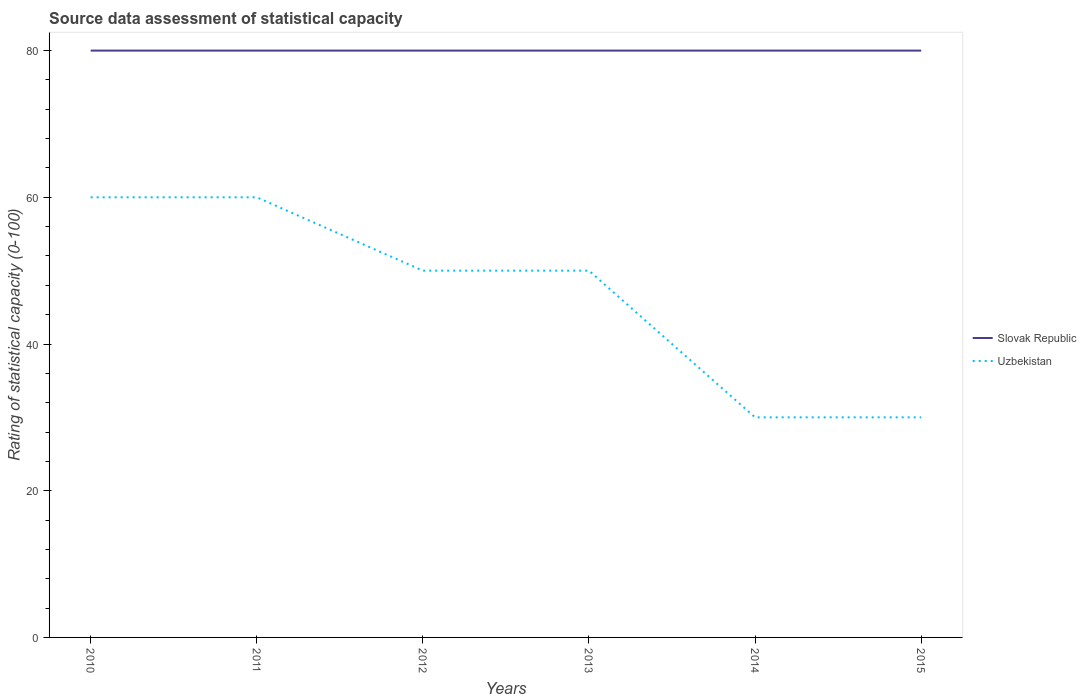Does the line corresponding to Slovak Republic intersect with the line corresponding to Uzbekistan?
Offer a very short reply. No. Is the number of lines equal to the number of legend labels?
Your answer should be compact. Yes. Across all years, what is the maximum rating of statistical capacity in Uzbekistan?
Your response must be concise. 30. In which year was the rating of statistical capacity in Uzbekistan maximum?
Provide a succinct answer. 2014. What is the difference between the highest and the lowest rating of statistical capacity in Slovak Republic?
Provide a short and direct response. 0. How many years are there in the graph?
Your answer should be compact. 6. What is the difference between two consecutive major ticks on the Y-axis?
Make the answer very short. 20. Are the values on the major ticks of Y-axis written in scientific E-notation?
Your response must be concise. No. Does the graph contain any zero values?
Make the answer very short. No. Where does the legend appear in the graph?
Keep it short and to the point. Center right. How are the legend labels stacked?
Your answer should be very brief. Vertical. What is the title of the graph?
Offer a very short reply. Source data assessment of statistical capacity. What is the label or title of the Y-axis?
Give a very brief answer. Rating of statistical capacity (0-100). What is the Rating of statistical capacity (0-100) in Slovak Republic in 2010?
Give a very brief answer. 80. What is the Rating of statistical capacity (0-100) of Uzbekistan in 2010?
Offer a very short reply. 60. What is the Rating of statistical capacity (0-100) of Slovak Republic in 2012?
Keep it short and to the point. 80. What is the Rating of statistical capacity (0-100) in Uzbekistan in 2012?
Your response must be concise. 50. What is the Rating of statistical capacity (0-100) of Slovak Republic in 2014?
Offer a terse response. 80. What is the Rating of statistical capacity (0-100) in Uzbekistan in 2014?
Your answer should be compact. 30. What is the Rating of statistical capacity (0-100) in Uzbekistan in 2015?
Offer a terse response. 30. Across all years, what is the minimum Rating of statistical capacity (0-100) in Slovak Republic?
Provide a short and direct response. 80. Across all years, what is the minimum Rating of statistical capacity (0-100) in Uzbekistan?
Offer a very short reply. 30. What is the total Rating of statistical capacity (0-100) of Slovak Republic in the graph?
Ensure brevity in your answer.  480. What is the total Rating of statistical capacity (0-100) of Uzbekistan in the graph?
Offer a very short reply. 280. What is the difference between the Rating of statistical capacity (0-100) in Slovak Republic in 2010 and that in 2011?
Provide a short and direct response. 0. What is the difference between the Rating of statistical capacity (0-100) in Uzbekistan in 2010 and that in 2011?
Your answer should be very brief. 0. What is the difference between the Rating of statistical capacity (0-100) of Slovak Republic in 2010 and that in 2012?
Give a very brief answer. 0. What is the difference between the Rating of statistical capacity (0-100) in Slovak Republic in 2010 and that in 2013?
Your answer should be compact. 0. What is the difference between the Rating of statistical capacity (0-100) in Slovak Republic in 2010 and that in 2014?
Your answer should be very brief. 0. What is the difference between the Rating of statistical capacity (0-100) in Slovak Republic in 2010 and that in 2015?
Your response must be concise. 0. What is the difference between the Rating of statistical capacity (0-100) of Slovak Republic in 2011 and that in 2012?
Provide a succinct answer. 0. What is the difference between the Rating of statistical capacity (0-100) in Slovak Republic in 2011 and that in 2013?
Give a very brief answer. 0. What is the difference between the Rating of statistical capacity (0-100) of Uzbekistan in 2011 and that in 2013?
Give a very brief answer. 10. What is the difference between the Rating of statistical capacity (0-100) of Slovak Republic in 2011 and that in 2014?
Provide a succinct answer. 0. What is the difference between the Rating of statistical capacity (0-100) in Uzbekistan in 2011 and that in 2014?
Make the answer very short. 30. What is the difference between the Rating of statistical capacity (0-100) of Uzbekistan in 2012 and that in 2015?
Keep it short and to the point. 20. What is the difference between the Rating of statistical capacity (0-100) of Slovak Republic in 2013 and that in 2015?
Offer a terse response. 0. What is the difference between the Rating of statistical capacity (0-100) in Uzbekistan in 2013 and that in 2015?
Offer a very short reply. 20. What is the difference between the Rating of statistical capacity (0-100) in Slovak Republic in 2010 and the Rating of statistical capacity (0-100) in Uzbekistan in 2015?
Give a very brief answer. 50. What is the difference between the Rating of statistical capacity (0-100) in Slovak Republic in 2011 and the Rating of statistical capacity (0-100) in Uzbekistan in 2012?
Give a very brief answer. 30. What is the difference between the Rating of statistical capacity (0-100) in Slovak Republic in 2011 and the Rating of statistical capacity (0-100) in Uzbekistan in 2013?
Your answer should be very brief. 30. What is the difference between the Rating of statistical capacity (0-100) of Slovak Republic in 2012 and the Rating of statistical capacity (0-100) of Uzbekistan in 2013?
Provide a short and direct response. 30. What is the difference between the Rating of statistical capacity (0-100) in Slovak Republic in 2012 and the Rating of statistical capacity (0-100) in Uzbekistan in 2014?
Ensure brevity in your answer.  50. What is the difference between the Rating of statistical capacity (0-100) of Slovak Republic in 2012 and the Rating of statistical capacity (0-100) of Uzbekistan in 2015?
Keep it short and to the point. 50. What is the difference between the Rating of statistical capacity (0-100) of Slovak Republic in 2013 and the Rating of statistical capacity (0-100) of Uzbekistan in 2014?
Your answer should be very brief. 50. What is the average Rating of statistical capacity (0-100) of Uzbekistan per year?
Offer a terse response. 46.67. In the year 2010, what is the difference between the Rating of statistical capacity (0-100) of Slovak Republic and Rating of statistical capacity (0-100) of Uzbekistan?
Give a very brief answer. 20. In the year 2011, what is the difference between the Rating of statistical capacity (0-100) in Slovak Republic and Rating of statistical capacity (0-100) in Uzbekistan?
Your response must be concise. 20. What is the ratio of the Rating of statistical capacity (0-100) of Slovak Republic in 2010 to that in 2011?
Offer a terse response. 1. What is the ratio of the Rating of statistical capacity (0-100) of Slovak Republic in 2010 to that in 2012?
Provide a succinct answer. 1. What is the ratio of the Rating of statistical capacity (0-100) in Slovak Republic in 2010 to that in 2014?
Your response must be concise. 1. What is the ratio of the Rating of statistical capacity (0-100) in Uzbekistan in 2010 to that in 2014?
Offer a very short reply. 2. What is the ratio of the Rating of statistical capacity (0-100) of Slovak Republic in 2010 to that in 2015?
Offer a terse response. 1. What is the ratio of the Rating of statistical capacity (0-100) in Slovak Republic in 2011 to that in 2013?
Ensure brevity in your answer.  1. What is the ratio of the Rating of statistical capacity (0-100) of Uzbekistan in 2011 to that in 2013?
Your response must be concise. 1.2. What is the ratio of the Rating of statistical capacity (0-100) of Uzbekistan in 2011 to that in 2015?
Your response must be concise. 2. What is the ratio of the Rating of statistical capacity (0-100) of Slovak Republic in 2012 to that in 2015?
Your response must be concise. 1. What is the ratio of the Rating of statistical capacity (0-100) of Slovak Republic in 2013 to that in 2014?
Your response must be concise. 1. What is the ratio of the Rating of statistical capacity (0-100) of Uzbekistan in 2013 to that in 2014?
Your answer should be compact. 1.67. What is the ratio of the Rating of statistical capacity (0-100) in Uzbekistan in 2014 to that in 2015?
Make the answer very short. 1. What is the difference between the highest and the second highest Rating of statistical capacity (0-100) of Slovak Republic?
Keep it short and to the point. 0. 